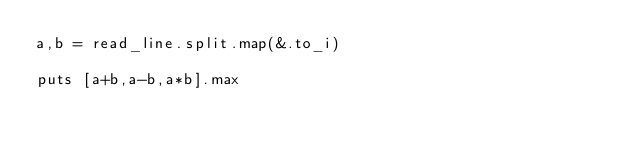<code> <loc_0><loc_0><loc_500><loc_500><_Crystal_>a,b = read_line.split.map(&.to_i)

puts [a+b,a-b,a*b].max</code> 